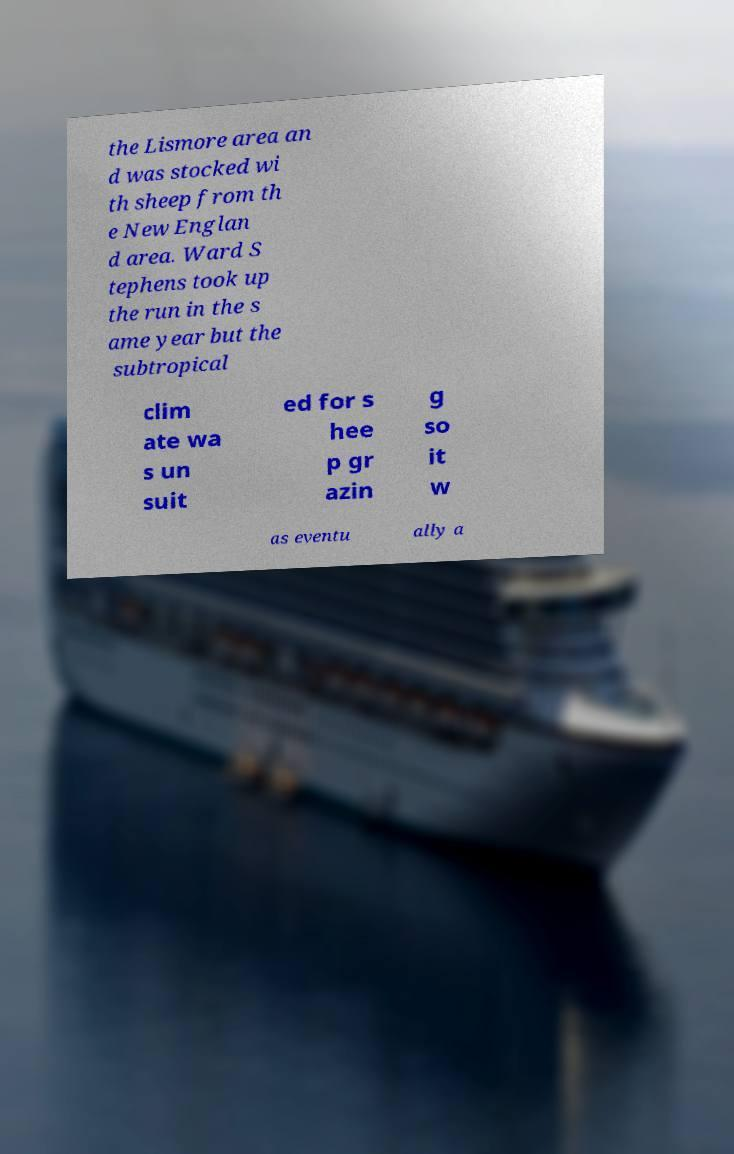Could you assist in decoding the text presented in this image and type it out clearly? the Lismore area an d was stocked wi th sheep from th e New Englan d area. Ward S tephens took up the run in the s ame year but the subtropical clim ate wa s un suit ed for s hee p gr azin g so it w as eventu ally a 